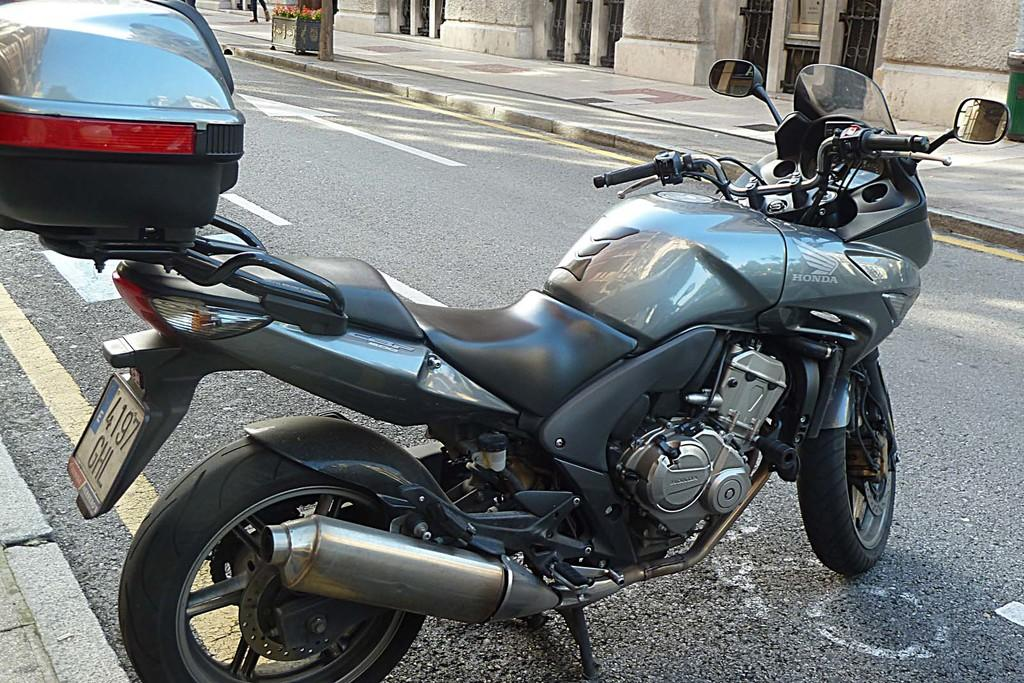What is the main subject of the image? The main subject of the image is a motorbike. Where is the motorbike located? The motorbike is on the road. What colors can be seen on the motorbike? The motorbike is black and grey in color. What can be seen in the background of the image? There is a dustbin and a building in the background of the image. How many people are pulling the motorbike in the image? There is no one pulling the motorbike in the image; it is stationary on the road. What type of crowd can be seen gathering around the motorbike in the image? There is no crowd present in the image; it only features the motorbike on the road and the background elements. 